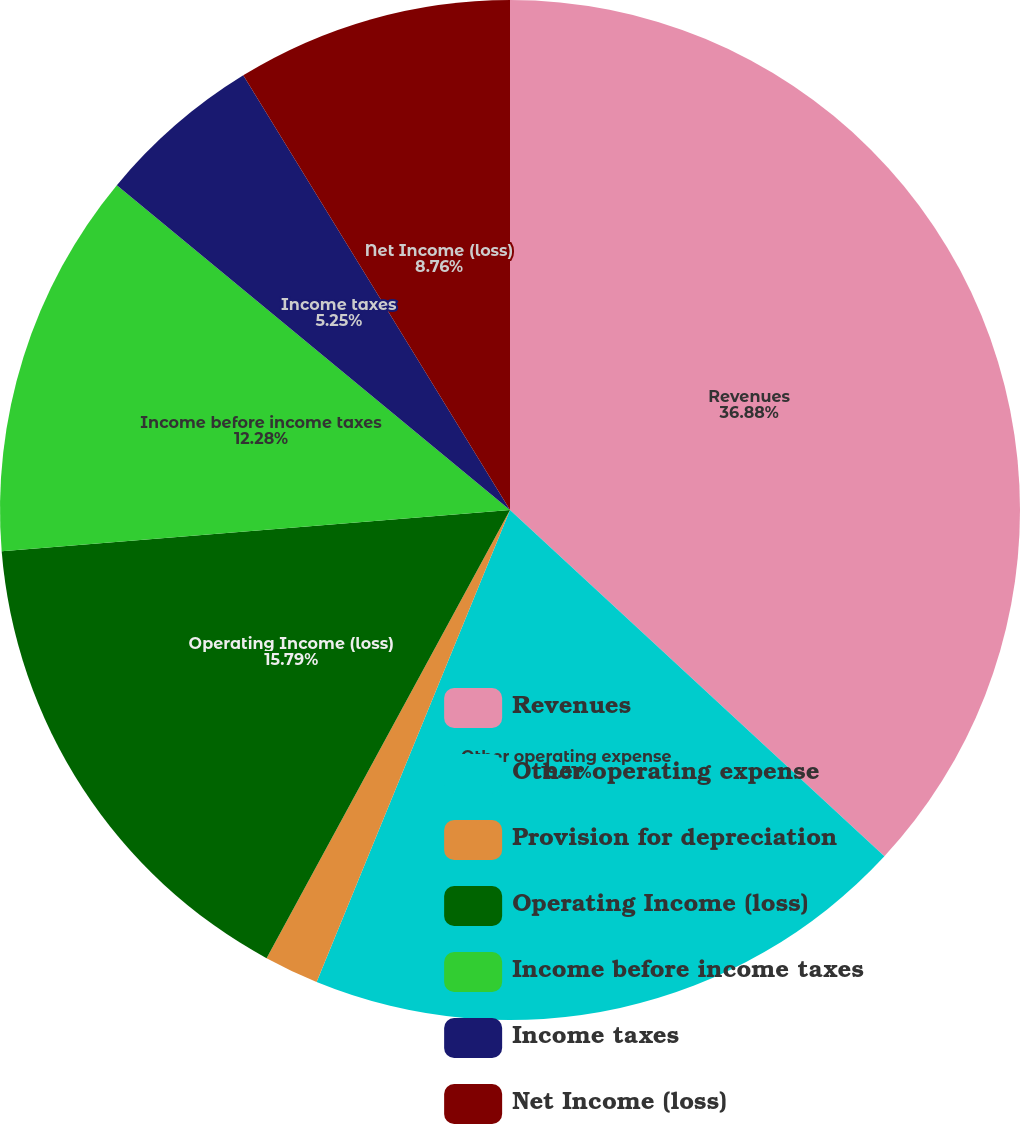Convert chart. <chart><loc_0><loc_0><loc_500><loc_500><pie_chart><fcel>Revenues<fcel>Other operating expense<fcel>Provision for depreciation<fcel>Operating Income (loss)<fcel>Income before income taxes<fcel>Income taxes<fcel>Net Income (loss)<nl><fcel>36.88%<fcel>19.31%<fcel>1.73%<fcel>15.79%<fcel>12.28%<fcel>5.25%<fcel>8.76%<nl></chart> 